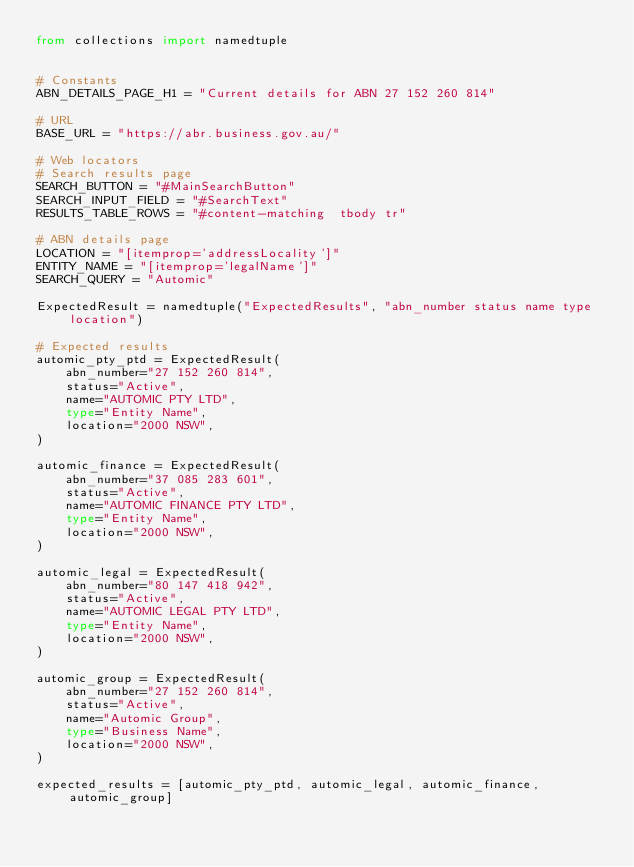<code> <loc_0><loc_0><loc_500><loc_500><_Python_>from collections import namedtuple


# Constants
ABN_DETAILS_PAGE_H1 = "Current details for ABN 27 152 260 814"

# URL
BASE_URL = "https://abr.business.gov.au/"

# Web locators
# Search results page
SEARCH_BUTTON = "#MainSearchButton"
SEARCH_INPUT_FIELD = "#SearchText"
RESULTS_TABLE_ROWS = "#content-matching  tbody tr"

# ABN details page
LOCATION = "[itemprop='addressLocality']"
ENTITY_NAME = "[itemprop='legalName']"
SEARCH_QUERY = "Automic"

ExpectedResult = namedtuple("ExpectedResults", "abn_number status name type location")

# Expected results
automic_pty_ptd = ExpectedResult(
    abn_number="27 152 260 814",
    status="Active",
    name="AUTOMIC PTY LTD",
    type="Entity Name",
    location="2000 NSW",
)

automic_finance = ExpectedResult(
    abn_number="37 085 283 601",
    status="Active",
    name="AUTOMIC FINANCE PTY LTD",
    type="Entity Name",
    location="2000 NSW",
)

automic_legal = ExpectedResult(
    abn_number="80 147 418 942",
    status="Active",
    name="AUTOMIC LEGAL PTY LTD",
    type="Entity Name",
    location="2000 NSW",
)

automic_group = ExpectedResult(
    abn_number="27 152 260 814",
    status="Active",
    name="Automic Group",
    type="Business Name",
    location="2000 NSW",
)

expected_results = [automic_pty_ptd, automic_legal, automic_finance, automic_group]</code> 